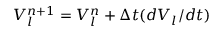<formula> <loc_0><loc_0><loc_500><loc_500>V _ { l } ^ { n + 1 } = V _ { l } ^ { n } + \Delta t ( d V _ { l } / d t )</formula> 